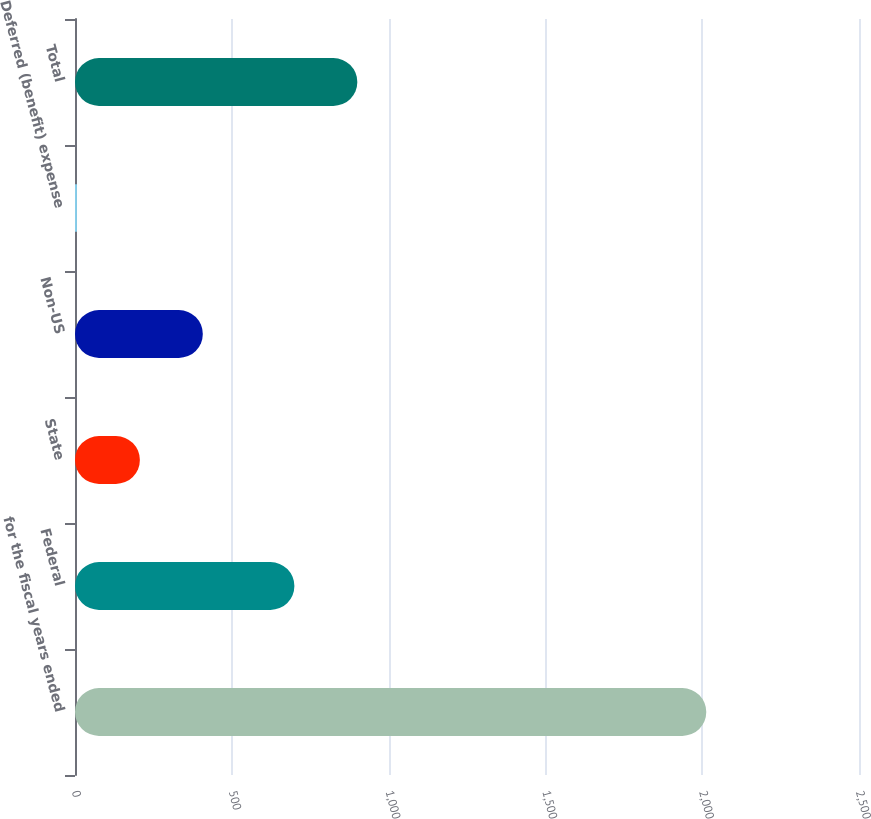Convert chart to OTSL. <chart><loc_0><loc_0><loc_500><loc_500><bar_chart><fcel>for the fiscal years ended<fcel>Federal<fcel>State<fcel>Non-US<fcel>Deferred (benefit) expense<fcel>Total<nl><fcel>2013<fcel>699.6<fcel>206.88<fcel>407.56<fcel>6.2<fcel>900.28<nl></chart> 